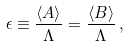Convert formula to latex. <formula><loc_0><loc_0><loc_500><loc_500>\epsilon \equiv \frac { \langle A \rangle } { \Lambda } = \frac { \langle B \rangle } { \Lambda } \, ,</formula> 